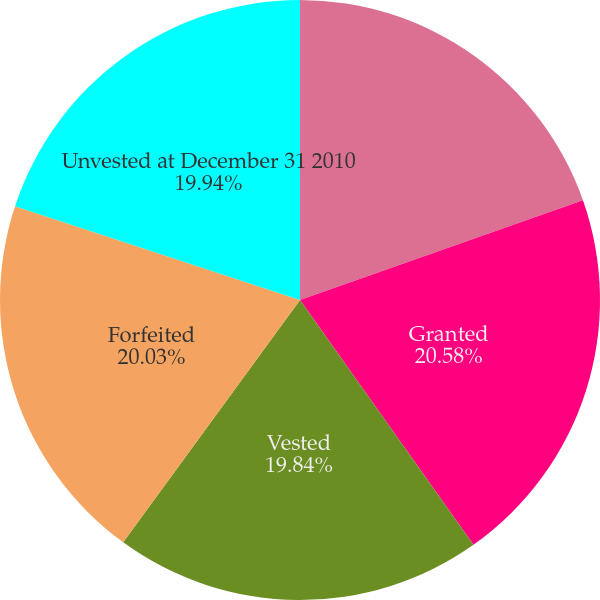Convert chart to OTSL. <chart><loc_0><loc_0><loc_500><loc_500><pie_chart><fcel>Unvested at December 31 2009<fcel>Granted<fcel>Vested<fcel>Forfeited<fcel>Unvested at December 31 2010<nl><fcel>19.61%<fcel>20.58%<fcel>19.84%<fcel>20.03%<fcel>19.94%<nl></chart> 